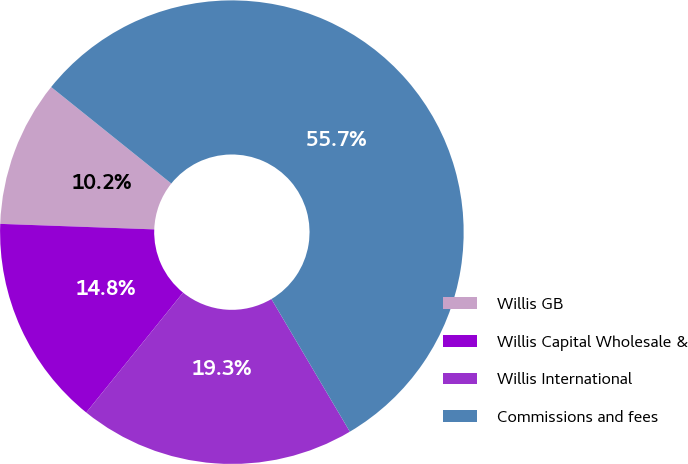Convert chart. <chart><loc_0><loc_0><loc_500><loc_500><pie_chart><fcel>Willis GB<fcel>Willis Capital Wholesale &<fcel>Willis International<fcel>Commissions and fees<nl><fcel>10.2%<fcel>14.76%<fcel>19.31%<fcel>55.73%<nl></chart> 